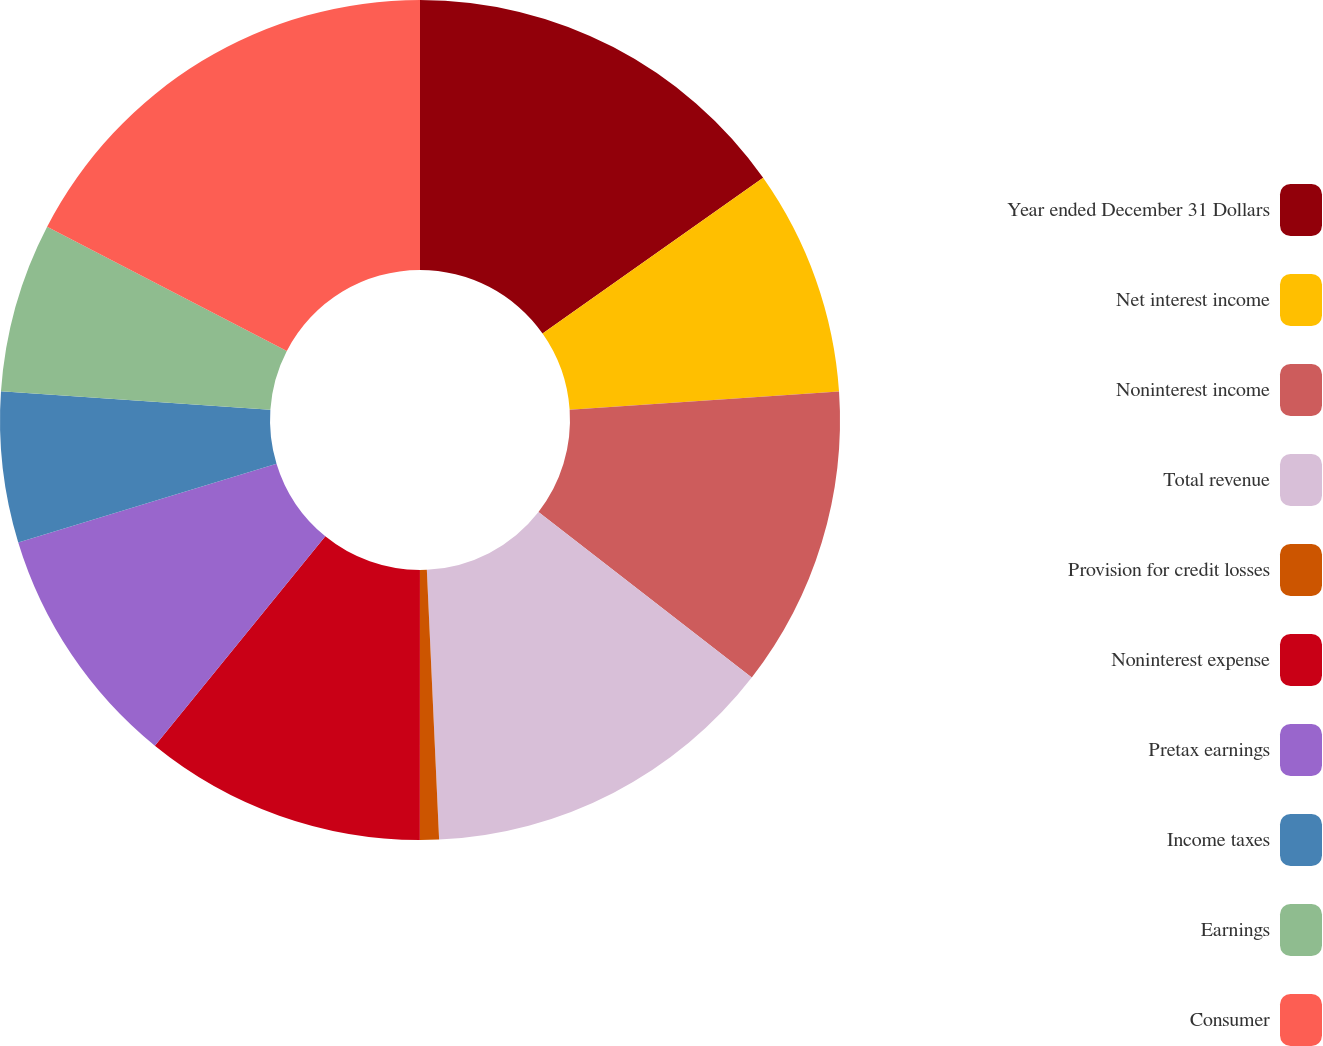Convert chart. <chart><loc_0><loc_0><loc_500><loc_500><pie_chart><fcel>Year ended December 31 Dollars<fcel>Net interest income<fcel>Noninterest income<fcel>Total revenue<fcel>Provision for credit losses<fcel>Noninterest expense<fcel>Pretax earnings<fcel>Income taxes<fcel>Earnings<fcel>Consumer<nl><fcel>15.22%<fcel>8.7%<fcel>11.59%<fcel>13.77%<fcel>0.73%<fcel>10.87%<fcel>9.42%<fcel>5.8%<fcel>6.52%<fcel>17.39%<nl></chart> 